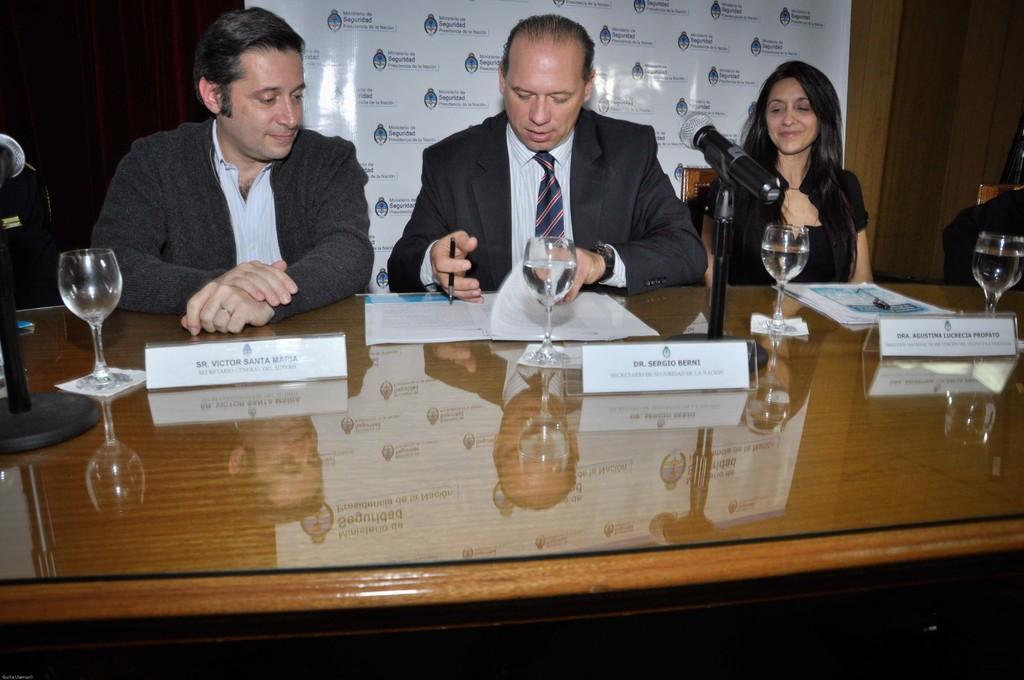Could you give a brief overview of what you see in this image? There are three persons in different dresses, sitting in front of the table on which, there are name boards, there are glasses and there are documents. In the background, there is a white color banner. And the background is dark in color. 